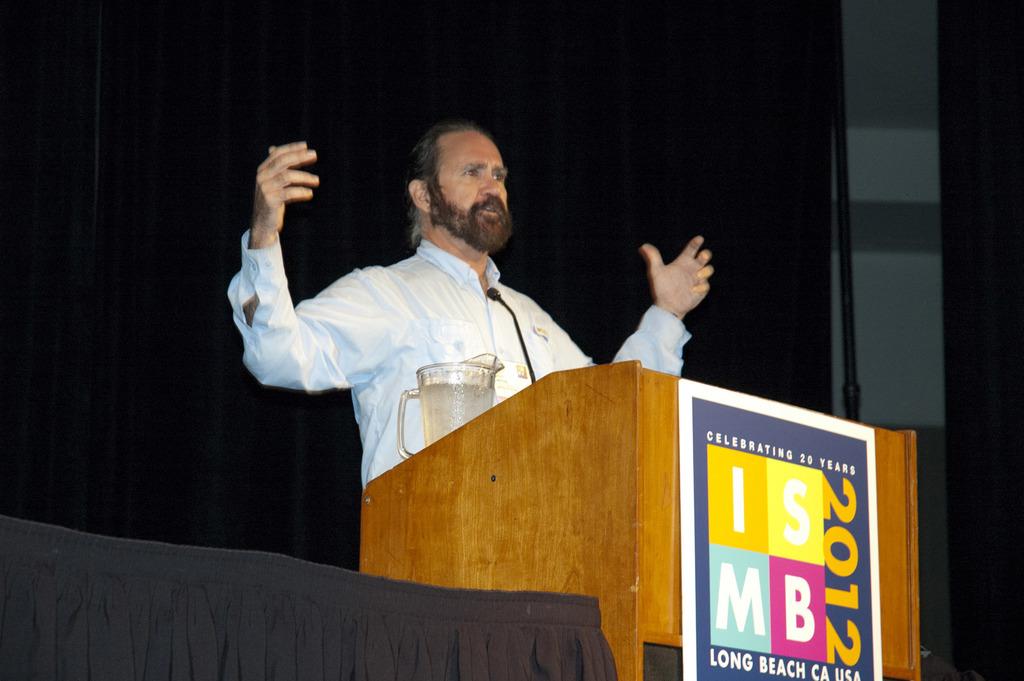What year was the conference in the photo?
Give a very brief answer. 2012. What country is on the poster?
Keep it short and to the point. Usa. 